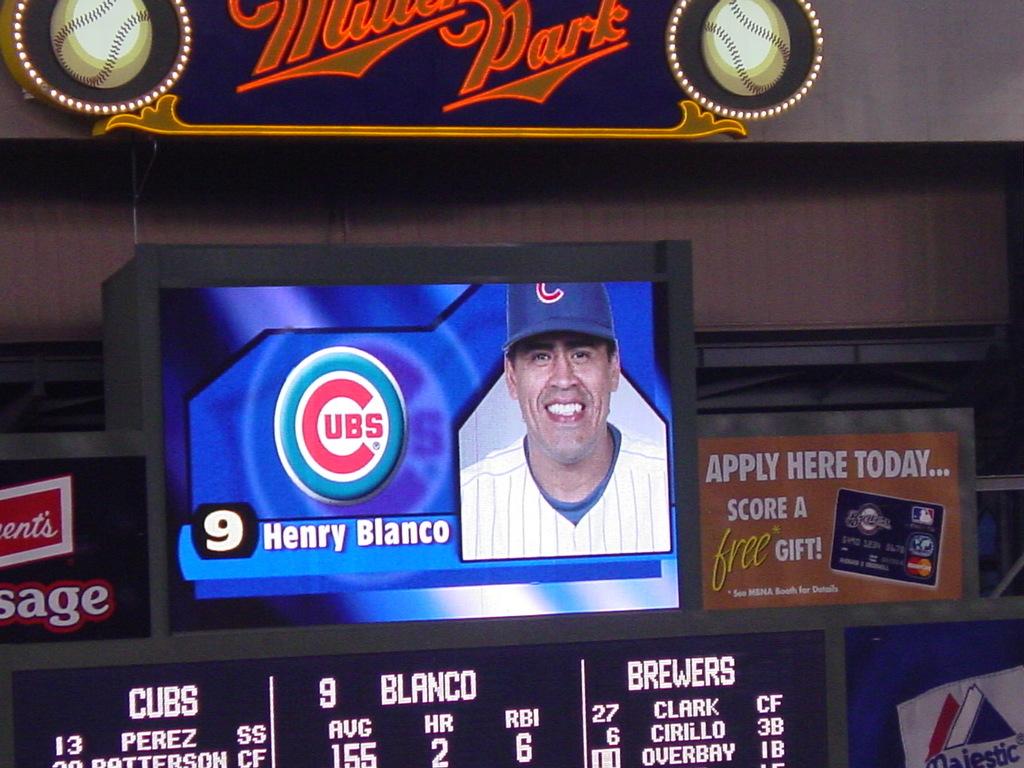What team does henry blanco play for?
Your response must be concise. Cubs. 